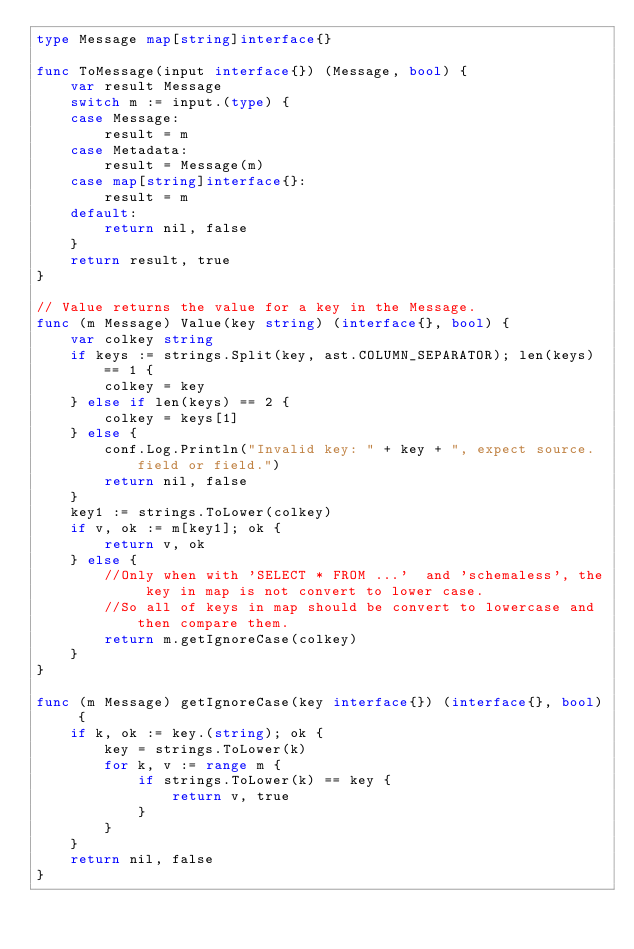<code> <loc_0><loc_0><loc_500><loc_500><_Go_>type Message map[string]interface{}

func ToMessage(input interface{}) (Message, bool) {
	var result Message
	switch m := input.(type) {
	case Message:
		result = m
	case Metadata:
		result = Message(m)
	case map[string]interface{}:
		result = m
	default:
		return nil, false
	}
	return result, true
}

// Value returns the value for a key in the Message.
func (m Message) Value(key string) (interface{}, bool) {
	var colkey string
	if keys := strings.Split(key, ast.COLUMN_SEPARATOR); len(keys) == 1 {
		colkey = key
	} else if len(keys) == 2 {
		colkey = keys[1]
	} else {
		conf.Log.Println("Invalid key: " + key + ", expect source.field or field.")
		return nil, false
	}
	key1 := strings.ToLower(colkey)
	if v, ok := m[key1]; ok {
		return v, ok
	} else {
		//Only when with 'SELECT * FROM ...'  and 'schemaless', the key in map is not convert to lower case.
		//So all of keys in map should be convert to lowercase and then compare them.
		return m.getIgnoreCase(colkey)
	}
}

func (m Message) getIgnoreCase(key interface{}) (interface{}, bool) {
	if k, ok := key.(string); ok {
		key = strings.ToLower(k)
		for k, v := range m {
			if strings.ToLower(k) == key {
				return v, true
			}
		}
	}
	return nil, false
}
</code> 